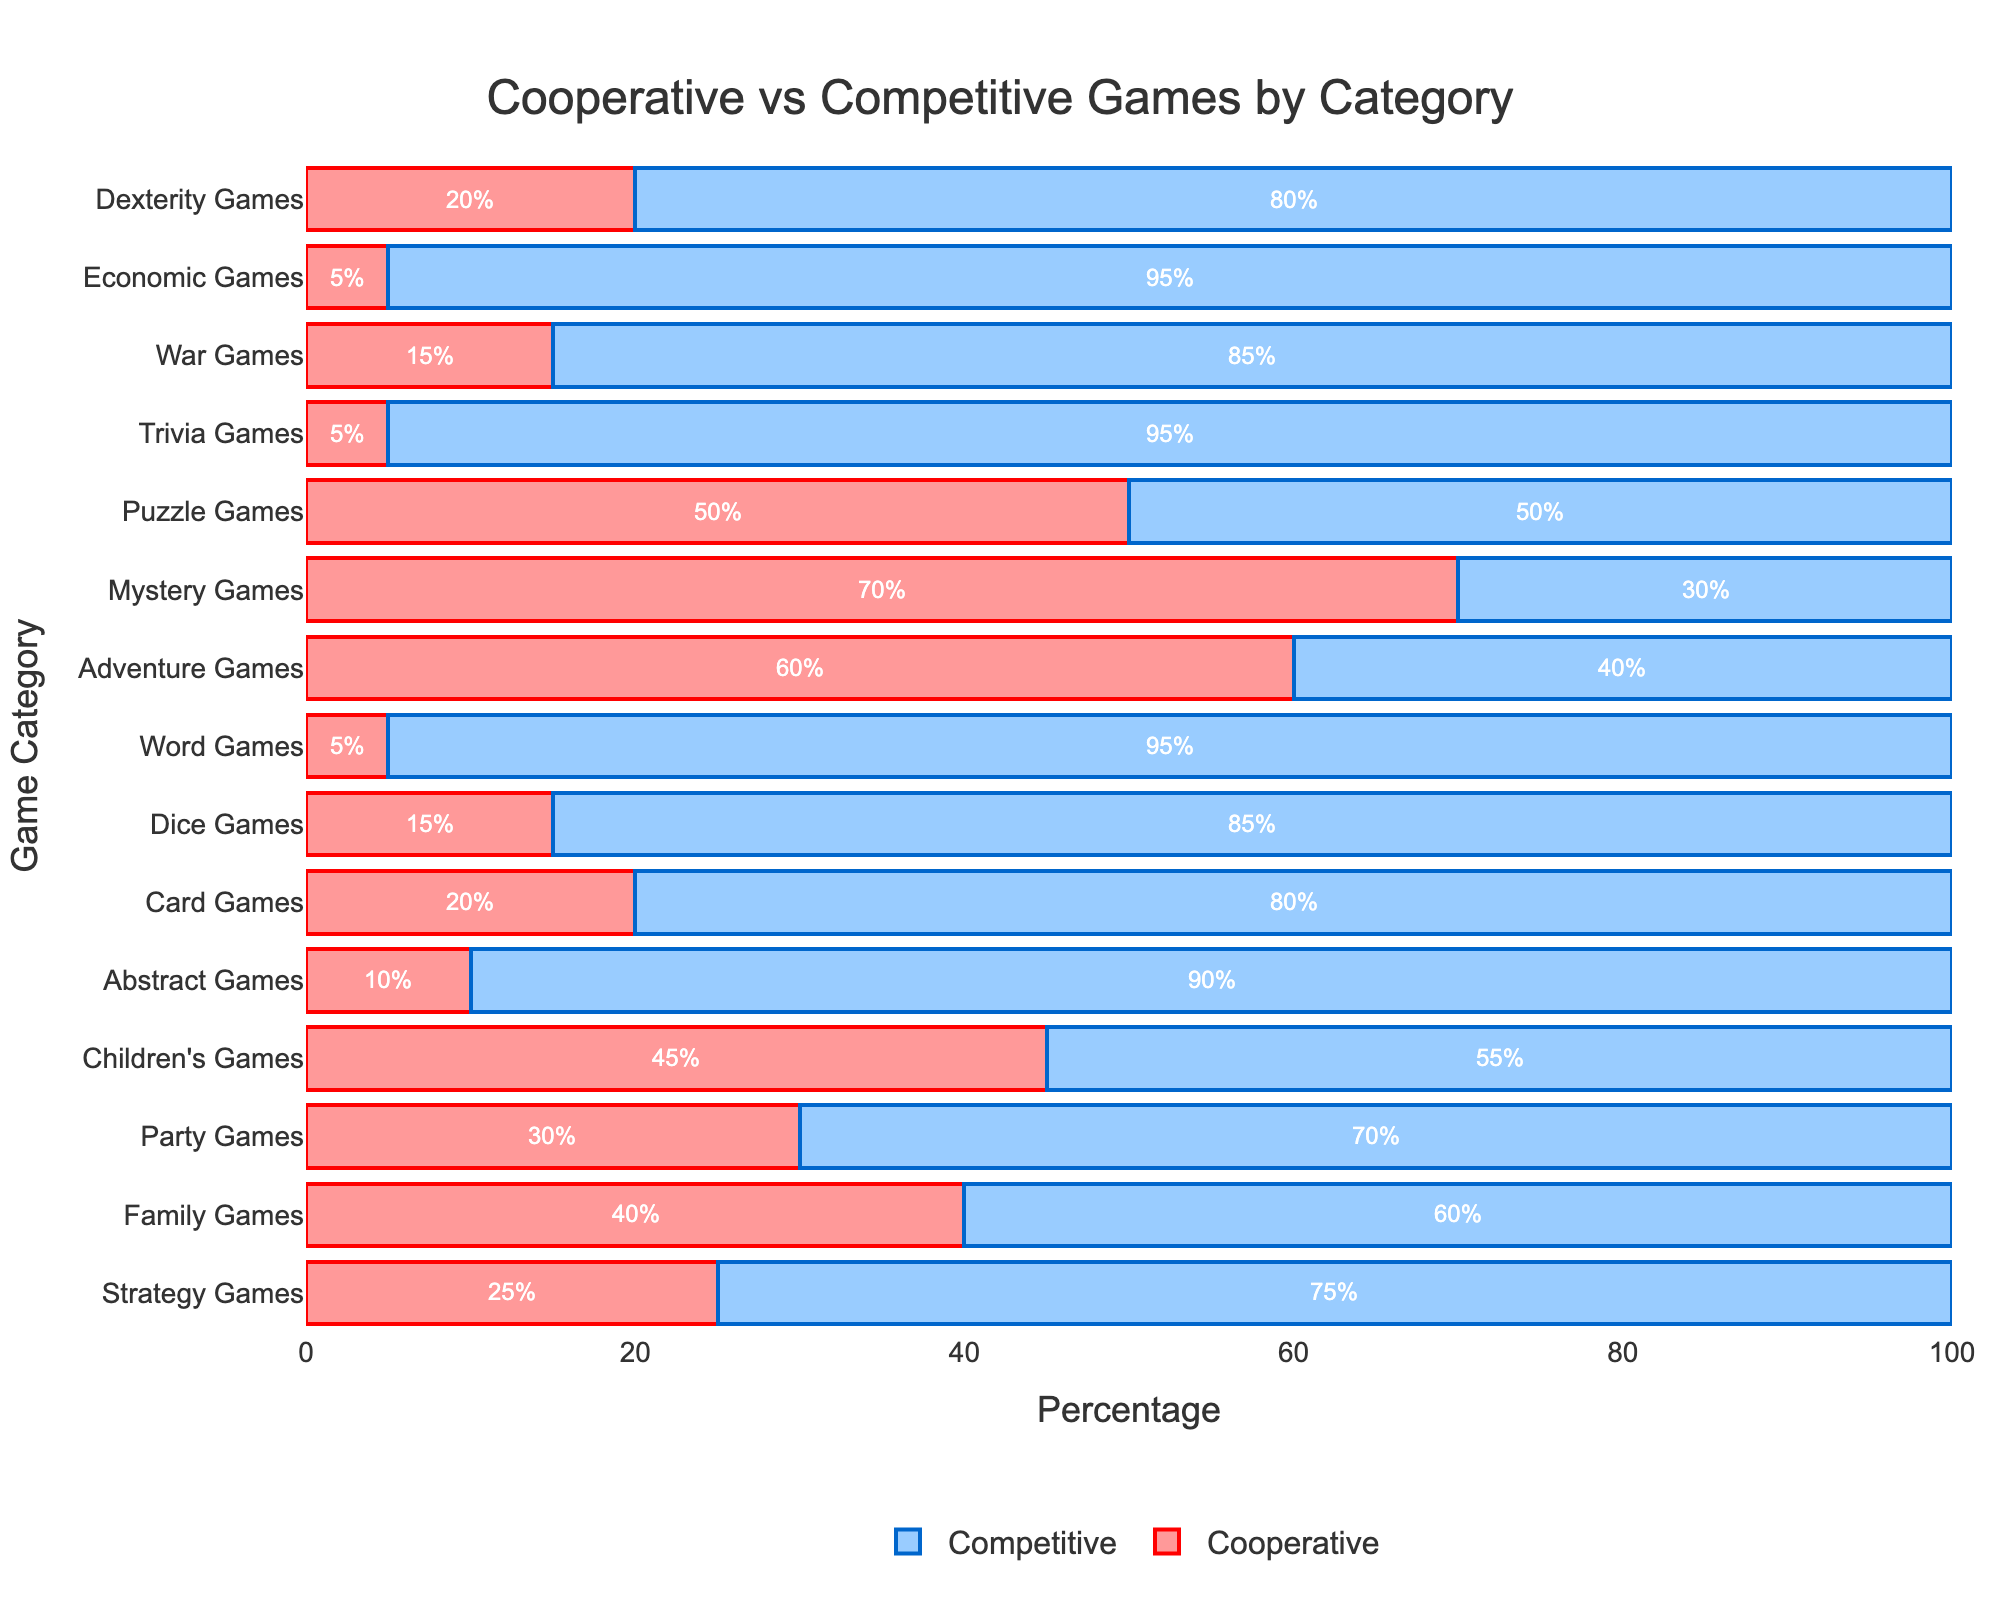what category has the highest percentage of cooperative games? The category with the highest percentage of cooperative games can be identified by looking at the red bars in the chart and finding the one with the longest red bar. Mystery Games have the highest percentage of cooperative games at 70%.
Answer: Mystery Games which category has the lowest percentage of competitive games? The category with the lowest percentage of competitive games can be found by identifying the shortest blue bar in the chart. The shortest blue bar corresponds to the Mystery Games category, which has 30% competitive games.
Answer: Mystery Games what is the combined percentage of cooperative games in Strategy Games, Card Games, and Word Games? To find the combined percentage of cooperative games in these categories, add up their respective cooperative game percentages. Strategy Games have 25%, Card Games have 20%, and Word Games have 5%. The total is 25% + 20% + 5% = 50%.
Answer: 50% which categories have exactly 40% cooperative games? Check the red bars and identify which categories have a bar length corresponding to 40%. The Family Games category has exactly 40% cooperative games.
Answer: Family Games do Family Games or Children's Games have a higher percentage of competitive games? Compare the lengths of the blue bars for Family Games and Children's Games. Family Games have 60% competitive games, while Children's Games have 55%. Therefore, Family Games have a higher percentage of competitive games.
Answer: Family Games what is the average percentage of competitive games in Adventure Games, Mystery Games, and Puzzle Games? Calculate the average by summing the competitive game percentages of these categories and then dividing by the number of categories. Adventure Games have 40%, Mystery Games have 30%, and Puzzle Games have 50%. The sum is 40% + 30% + 50% = 120%. The average is 120% / 3 = 40%.
Answer: 40% which categories have a more significant percentage of competitive games than cooperative games? Compare the lengths of the red and blue bars within each category. If the blue bar is longer, the category has more competitive games. Categories with more competitive games than cooperative games include Strategy Games, Family Games, Party Games, Abstract Games, Card Games, Dice Games, Word Games, Trivia Games, War Games, and Economic Games.
Answer: Strategy Games, Family Games, Party Games, Abstract Games, Card Games, Dice Games, Word Games, Trivia Games, War Games, Economic Games 